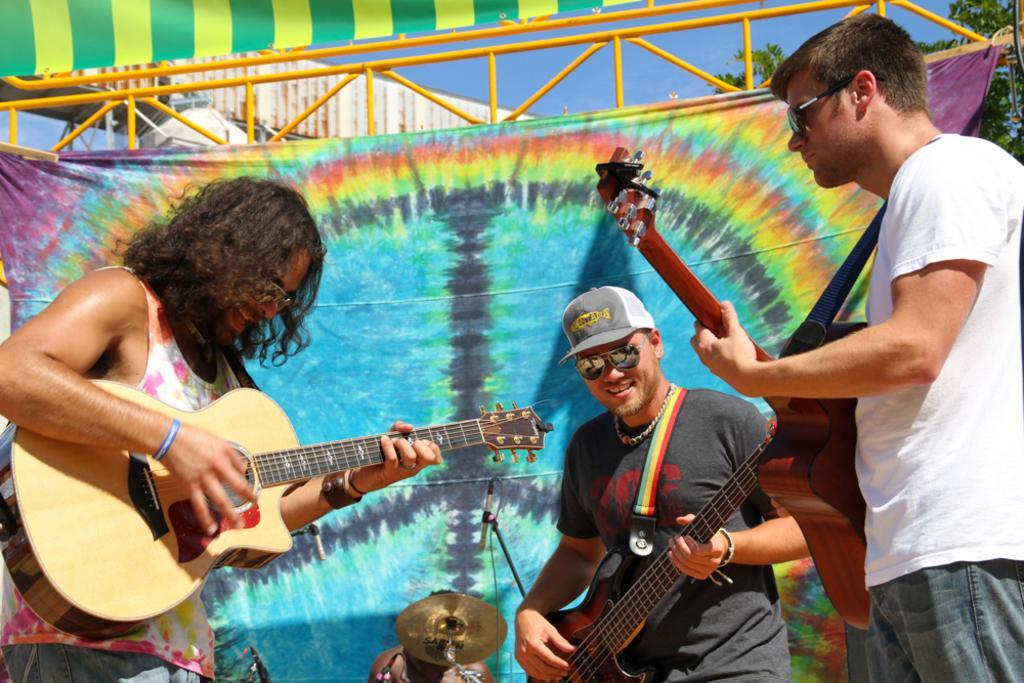Please provide a concise description of this image. There are three persons standing and playing guitar. The center person wearing a black t shirt wearing a cap and goggles. In the background there is a colorful banner. Also a person is sitting in front of a cymbal. In the background there are trees and sky. 